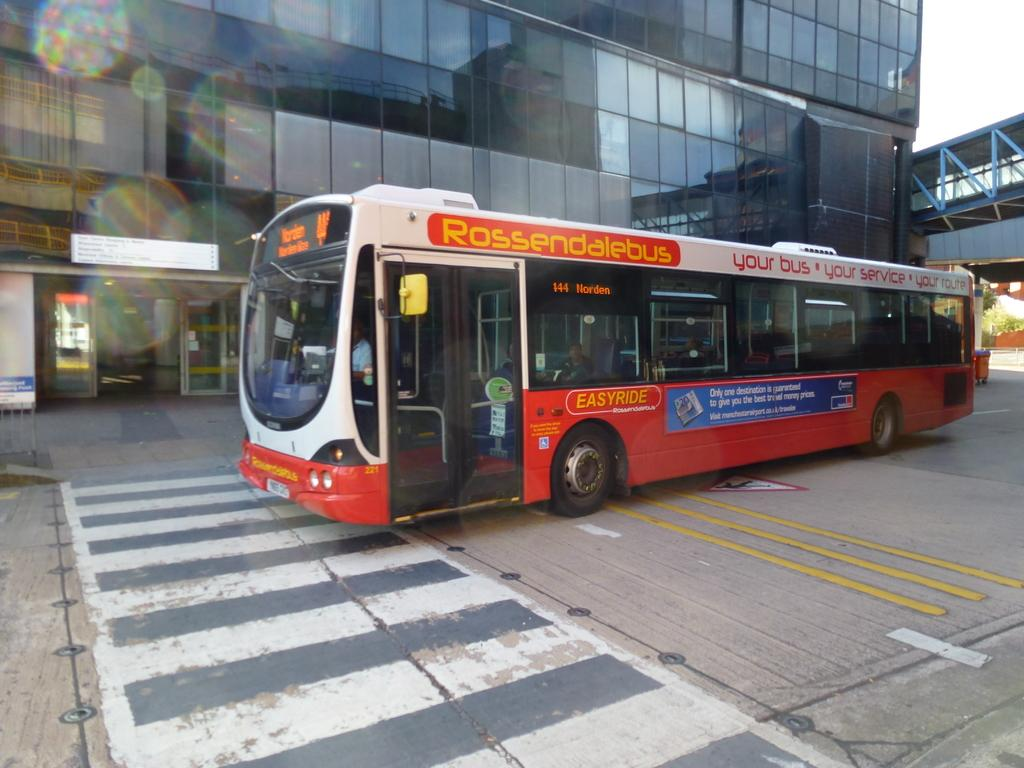What type of vehicle is on the road in the image? There is a bus on the road in the image. Who or what is inside the bus? There are people seated in the bus. What can be seen in the background of the image? There is a building and a bridge in the background of the image. What type of linen is draped over the bedroom furniture in the image? There is no linen or bedroom furniture present in the image; it features a bus on the road with people inside and a background with a building and a bridge. 